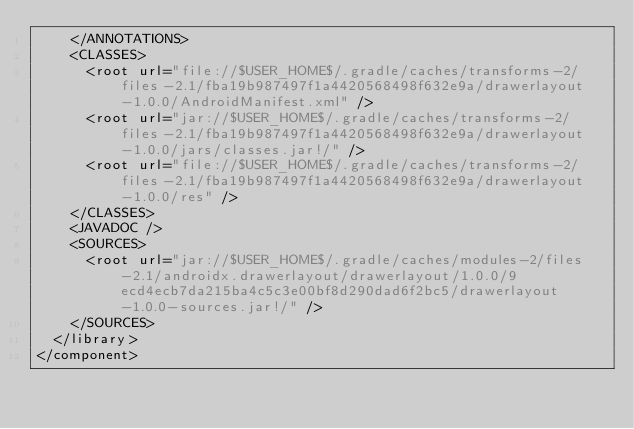Convert code to text. <code><loc_0><loc_0><loc_500><loc_500><_XML_>    </ANNOTATIONS>
    <CLASSES>
      <root url="file://$USER_HOME$/.gradle/caches/transforms-2/files-2.1/fba19b987497f1a4420568498f632e9a/drawerlayout-1.0.0/AndroidManifest.xml" />
      <root url="jar://$USER_HOME$/.gradle/caches/transforms-2/files-2.1/fba19b987497f1a4420568498f632e9a/drawerlayout-1.0.0/jars/classes.jar!/" />
      <root url="file://$USER_HOME$/.gradle/caches/transforms-2/files-2.1/fba19b987497f1a4420568498f632e9a/drawerlayout-1.0.0/res" />
    </CLASSES>
    <JAVADOC />
    <SOURCES>
      <root url="jar://$USER_HOME$/.gradle/caches/modules-2/files-2.1/androidx.drawerlayout/drawerlayout/1.0.0/9ecd4ecb7da215ba4c5c3e00bf8d290dad6f2bc5/drawerlayout-1.0.0-sources.jar!/" />
    </SOURCES>
  </library>
</component></code> 